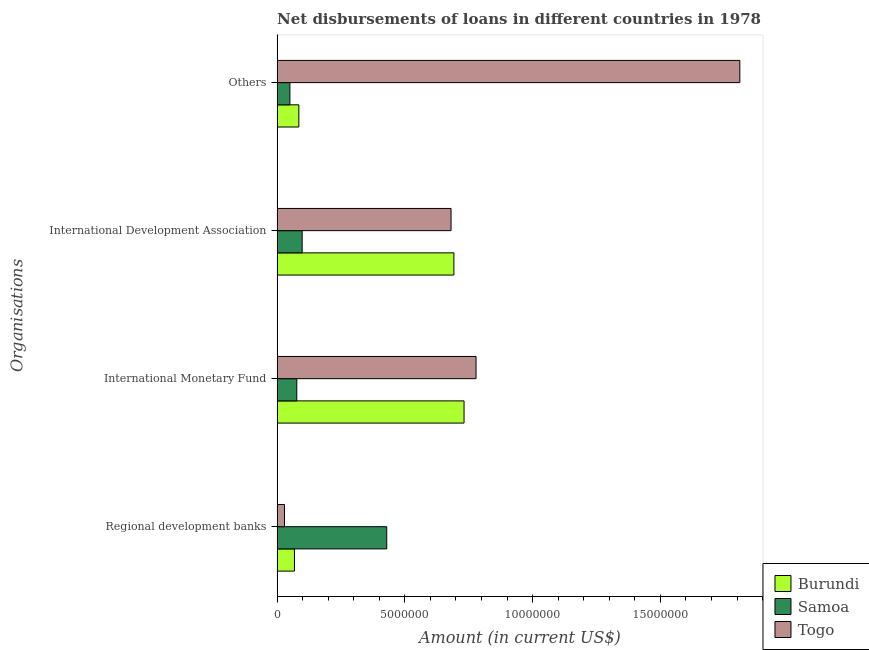How many different coloured bars are there?
Give a very brief answer. 3. How many groups of bars are there?
Offer a very short reply. 4. Are the number of bars per tick equal to the number of legend labels?
Your answer should be compact. Yes. How many bars are there on the 2nd tick from the top?
Offer a very short reply. 3. What is the label of the 3rd group of bars from the top?
Your answer should be compact. International Monetary Fund. What is the amount of loan disimbursed by regional development banks in Samoa?
Provide a succinct answer. 4.29e+06. Across all countries, what is the maximum amount of loan disimbursed by other organisations?
Your answer should be very brief. 1.81e+07. Across all countries, what is the minimum amount of loan disimbursed by international development association?
Offer a terse response. 9.80e+05. In which country was the amount of loan disimbursed by international development association maximum?
Provide a succinct answer. Burundi. In which country was the amount of loan disimbursed by regional development banks minimum?
Offer a very short reply. Togo. What is the total amount of loan disimbursed by international development association in the graph?
Your response must be concise. 1.47e+07. What is the difference between the amount of loan disimbursed by regional development banks in Burundi and that in Samoa?
Keep it short and to the point. -3.61e+06. What is the difference between the amount of loan disimbursed by international monetary fund in Burundi and the amount of loan disimbursed by international development association in Samoa?
Your answer should be compact. 6.34e+06. What is the average amount of loan disimbursed by regional development banks per country?
Keep it short and to the point. 1.75e+06. What is the difference between the amount of loan disimbursed by other organisations and amount of loan disimbursed by international development association in Samoa?
Keep it short and to the point. -4.80e+05. What is the ratio of the amount of loan disimbursed by international development association in Burundi to that in Samoa?
Keep it short and to the point. 7.06. What is the difference between the highest and the second highest amount of loan disimbursed by other organisations?
Your answer should be compact. 1.73e+07. What is the difference between the highest and the lowest amount of loan disimbursed by regional development banks?
Offer a terse response. 4.00e+06. Is it the case that in every country, the sum of the amount of loan disimbursed by international development association and amount of loan disimbursed by regional development banks is greater than the sum of amount of loan disimbursed by international monetary fund and amount of loan disimbursed by other organisations?
Keep it short and to the point. Yes. What does the 3rd bar from the top in Others represents?
Make the answer very short. Burundi. What does the 3rd bar from the bottom in Others represents?
Keep it short and to the point. Togo. How many countries are there in the graph?
Your answer should be compact. 3. What is the difference between two consecutive major ticks on the X-axis?
Ensure brevity in your answer.  5.00e+06. Does the graph contain any zero values?
Make the answer very short. No. How many legend labels are there?
Your answer should be compact. 3. How are the legend labels stacked?
Provide a short and direct response. Vertical. What is the title of the graph?
Offer a very short reply. Net disbursements of loans in different countries in 1978. Does "Syrian Arab Republic" appear as one of the legend labels in the graph?
Give a very brief answer. No. What is the label or title of the Y-axis?
Your response must be concise. Organisations. What is the Amount (in current US$) in Burundi in Regional development banks?
Your answer should be compact. 6.79e+05. What is the Amount (in current US$) of Samoa in Regional development banks?
Your answer should be very brief. 4.29e+06. What is the Amount (in current US$) of Togo in Regional development banks?
Offer a terse response. 2.88e+05. What is the Amount (in current US$) in Burundi in International Monetary Fund?
Ensure brevity in your answer.  7.32e+06. What is the Amount (in current US$) of Samoa in International Monetary Fund?
Make the answer very short. 7.70e+05. What is the Amount (in current US$) in Togo in International Monetary Fund?
Your answer should be very brief. 7.79e+06. What is the Amount (in current US$) in Burundi in International Development Association?
Offer a terse response. 6.92e+06. What is the Amount (in current US$) of Samoa in International Development Association?
Your response must be concise. 9.80e+05. What is the Amount (in current US$) of Togo in International Development Association?
Make the answer very short. 6.81e+06. What is the Amount (in current US$) of Burundi in Others?
Ensure brevity in your answer.  8.50e+05. What is the Amount (in current US$) of Samoa in Others?
Offer a terse response. 5.00e+05. What is the Amount (in current US$) of Togo in Others?
Provide a succinct answer. 1.81e+07. Across all Organisations, what is the maximum Amount (in current US$) of Burundi?
Offer a very short reply. 7.32e+06. Across all Organisations, what is the maximum Amount (in current US$) of Samoa?
Your response must be concise. 4.29e+06. Across all Organisations, what is the maximum Amount (in current US$) in Togo?
Offer a terse response. 1.81e+07. Across all Organisations, what is the minimum Amount (in current US$) in Burundi?
Make the answer very short. 6.79e+05. Across all Organisations, what is the minimum Amount (in current US$) in Samoa?
Keep it short and to the point. 5.00e+05. Across all Organisations, what is the minimum Amount (in current US$) of Togo?
Provide a succinct answer. 2.88e+05. What is the total Amount (in current US$) in Burundi in the graph?
Make the answer very short. 1.58e+07. What is the total Amount (in current US$) of Samoa in the graph?
Provide a succinct answer. 6.54e+06. What is the total Amount (in current US$) of Togo in the graph?
Provide a succinct answer. 3.30e+07. What is the difference between the Amount (in current US$) in Burundi in Regional development banks and that in International Monetary Fund?
Offer a terse response. -6.64e+06. What is the difference between the Amount (in current US$) in Samoa in Regional development banks and that in International Monetary Fund?
Offer a terse response. 3.52e+06. What is the difference between the Amount (in current US$) in Togo in Regional development banks and that in International Monetary Fund?
Offer a very short reply. -7.50e+06. What is the difference between the Amount (in current US$) in Burundi in Regional development banks and that in International Development Association?
Keep it short and to the point. -6.24e+06. What is the difference between the Amount (in current US$) of Samoa in Regional development banks and that in International Development Association?
Your answer should be compact. 3.31e+06. What is the difference between the Amount (in current US$) in Togo in Regional development banks and that in International Development Association?
Your answer should be compact. -6.52e+06. What is the difference between the Amount (in current US$) in Burundi in Regional development banks and that in Others?
Provide a short and direct response. -1.71e+05. What is the difference between the Amount (in current US$) in Samoa in Regional development banks and that in Others?
Offer a terse response. 3.79e+06. What is the difference between the Amount (in current US$) of Togo in Regional development banks and that in Others?
Your answer should be compact. -1.78e+07. What is the difference between the Amount (in current US$) in Burundi in International Monetary Fund and that in International Development Association?
Make the answer very short. 3.97e+05. What is the difference between the Amount (in current US$) of Togo in International Monetary Fund and that in International Development Association?
Ensure brevity in your answer.  9.79e+05. What is the difference between the Amount (in current US$) in Burundi in International Monetary Fund and that in Others?
Give a very brief answer. 6.47e+06. What is the difference between the Amount (in current US$) of Togo in International Monetary Fund and that in Others?
Keep it short and to the point. -1.03e+07. What is the difference between the Amount (in current US$) in Burundi in International Development Association and that in Others?
Keep it short and to the point. 6.07e+06. What is the difference between the Amount (in current US$) of Samoa in International Development Association and that in Others?
Give a very brief answer. 4.80e+05. What is the difference between the Amount (in current US$) of Togo in International Development Association and that in Others?
Offer a very short reply. -1.13e+07. What is the difference between the Amount (in current US$) of Burundi in Regional development banks and the Amount (in current US$) of Samoa in International Monetary Fund?
Provide a succinct answer. -9.10e+04. What is the difference between the Amount (in current US$) of Burundi in Regional development banks and the Amount (in current US$) of Togo in International Monetary Fund?
Your answer should be compact. -7.11e+06. What is the difference between the Amount (in current US$) of Samoa in Regional development banks and the Amount (in current US$) of Togo in International Monetary Fund?
Give a very brief answer. -3.50e+06. What is the difference between the Amount (in current US$) in Burundi in Regional development banks and the Amount (in current US$) in Samoa in International Development Association?
Keep it short and to the point. -3.01e+05. What is the difference between the Amount (in current US$) in Burundi in Regional development banks and the Amount (in current US$) in Togo in International Development Association?
Your answer should be very brief. -6.13e+06. What is the difference between the Amount (in current US$) in Samoa in Regional development banks and the Amount (in current US$) in Togo in International Development Association?
Your answer should be compact. -2.52e+06. What is the difference between the Amount (in current US$) in Burundi in Regional development banks and the Amount (in current US$) in Samoa in Others?
Provide a short and direct response. 1.79e+05. What is the difference between the Amount (in current US$) in Burundi in Regional development banks and the Amount (in current US$) in Togo in Others?
Ensure brevity in your answer.  -1.74e+07. What is the difference between the Amount (in current US$) in Samoa in Regional development banks and the Amount (in current US$) in Togo in Others?
Your answer should be very brief. -1.38e+07. What is the difference between the Amount (in current US$) in Burundi in International Monetary Fund and the Amount (in current US$) in Samoa in International Development Association?
Ensure brevity in your answer.  6.34e+06. What is the difference between the Amount (in current US$) in Burundi in International Monetary Fund and the Amount (in current US$) in Togo in International Development Association?
Your response must be concise. 5.09e+05. What is the difference between the Amount (in current US$) of Samoa in International Monetary Fund and the Amount (in current US$) of Togo in International Development Association?
Keep it short and to the point. -6.04e+06. What is the difference between the Amount (in current US$) of Burundi in International Monetary Fund and the Amount (in current US$) of Samoa in Others?
Your answer should be compact. 6.82e+06. What is the difference between the Amount (in current US$) in Burundi in International Monetary Fund and the Amount (in current US$) in Togo in Others?
Make the answer very short. -1.08e+07. What is the difference between the Amount (in current US$) of Samoa in International Monetary Fund and the Amount (in current US$) of Togo in Others?
Provide a succinct answer. -1.73e+07. What is the difference between the Amount (in current US$) in Burundi in International Development Association and the Amount (in current US$) in Samoa in Others?
Provide a succinct answer. 6.42e+06. What is the difference between the Amount (in current US$) of Burundi in International Development Association and the Amount (in current US$) of Togo in Others?
Give a very brief answer. -1.12e+07. What is the difference between the Amount (in current US$) in Samoa in International Development Association and the Amount (in current US$) in Togo in Others?
Provide a succinct answer. -1.71e+07. What is the average Amount (in current US$) of Burundi per Organisations?
Ensure brevity in your answer.  3.94e+06. What is the average Amount (in current US$) of Samoa per Organisations?
Ensure brevity in your answer.  1.64e+06. What is the average Amount (in current US$) of Togo per Organisations?
Provide a succinct answer. 8.25e+06. What is the difference between the Amount (in current US$) of Burundi and Amount (in current US$) of Samoa in Regional development banks?
Your answer should be compact. -3.61e+06. What is the difference between the Amount (in current US$) of Burundi and Amount (in current US$) of Togo in Regional development banks?
Ensure brevity in your answer.  3.91e+05. What is the difference between the Amount (in current US$) in Samoa and Amount (in current US$) in Togo in Regional development banks?
Provide a short and direct response. 4.00e+06. What is the difference between the Amount (in current US$) in Burundi and Amount (in current US$) in Samoa in International Monetary Fund?
Keep it short and to the point. 6.55e+06. What is the difference between the Amount (in current US$) of Burundi and Amount (in current US$) of Togo in International Monetary Fund?
Provide a succinct answer. -4.70e+05. What is the difference between the Amount (in current US$) in Samoa and Amount (in current US$) in Togo in International Monetary Fund?
Your answer should be very brief. -7.02e+06. What is the difference between the Amount (in current US$) in Burundi and Amount (in current US$) in Samoa in International Development Association?
Provide a short and direct response. 5.94e+06. What is the difference between the Amount (in current US$) of Burundi and Amount (in current US$) of Togo in International Development Association?
Your answer should be compact. 1.12e+05. What is the difference between the Amount (in current US$) of Samoa and Amount (in current US$) of Togo in International Development Association?
Offer a very short reply. -5.83e+06. What is the difference between the Amount (in current US$) in Burundi and Amount (in current US$) in Samoa in Others?
Your answer should be compact. 3.50e+05. What is the difference between the Amount (in current US$) in Burundi and Amount (in current US$) in Togo in Others?
Provide a short and direct response. -1.73e+07. What is the difference between the Amount (in current US$) in Samoa and Amount (in current US$) in Togo in Others?
Make the answer very short. -1.76e+07. What is the ratio of the Amount (in current US$) of Burundi in Regional development banks to that in International Monetary Fund?
Provide a short and direct response. 0.09. What is the ratio of the Amount (in current US$) in Samoa in Regional development banks to that in International Monetary Fund?
Offer a terse response. 5.57. What is the ratio of the Amount (in current US$) in Togo in Regional development banks to that in International Monetary Fund?
Ensure brevity in your answer.  0.04. What is the ratio of the Amount (in current US$) of Burundi in Regional development banks to that in International Development Association?
Provide a short and direct response. 0.1. What is the ratio of the Amount (in current US$) in Samoa in Regional development banks to that in International Development Association?
Offer a very short reply. 4.38. What is the ratio of the Amount (in current US$) in Togo in Regional development banks to that in International Development Association?
Make the answer very short. 0.04. What is the ratio of the Amount (in current US$) of Burundi in Regional development banks to that in Others?
Offer a very short reply. 0.8. What is the ratio of the Amount (in current US$) of Samoa in Regional development banks to that in Others?
Make the answer very short. 8.58. What is the ratio of the Amount (in current US$) of Togo in Regional development banks to that in Others?
Ensure brevity in your answer.  0.02. What is the ratio of the Amount (in current US$) in Burundi in International Monetary Fund to that in International Development Association?
Provide a short and direct response. 1.06. What is the ratio of the Amount (in current US$) of Samoa in International Monetary Fund to that in International Development Association?
Offer a very short reply. 0.79. What is the ratio of the Amount (in current US$) in Togo in International Monetary Fund to that in International Development Association?
Give a very brief answer. 1.14. What is the ratio of the Amount (in current US$) in Burundi in International Monetary Fund to that in Others?
Your answer should be very brief. 8.61. What is the ratio of the Amount (in current US$) in Samoa in International Monetary Fund to that in Others?
Offer a very short reply. 1.54. What is the ratio of the Amount (in current US$) of Togo in International Monetary Fund to that in Others?
Your answer should be compact. 0.43. What is the ratio of the Amount (in current US$) in Burundi in International Development Association to that in Others?
Your answer should be very brief. 8.14. What is the ratio of the Amount (in current US$) of Samoa in International Development Association to that in Others?
Offer a terse response. 1.96. What is the ratio of the Amount (in current US$) of Togo in International Development Association to that in Others?
Keep it short and to the point. 0.38. What is the difference between the highest and the second highest Amount (in current US$) of Burundi?
Offer a terse response. 3.97e+05. What is the difference between the highest and the second highest Amount (in current US$) of Samoa?
Ensure brevity in your answer.  3.31e+06. What is the difference between the highest and the second highest Amount (in current US$) of Togo?
Your answer should be very brief. 1.03e+07. What is the difference between the highest and the lowest Amount (in current US$) of Burundi?
Make the answer very short. 6.64e+06. What is the difference between the highest and the lowest Amount (in current US$) of Samoa?
Provide a succinct answer. 3.79e+06. What is the difference between the highest and the lowest Amount (in current US$) of Togo?
Offer a terse response. 1.78e+07. 